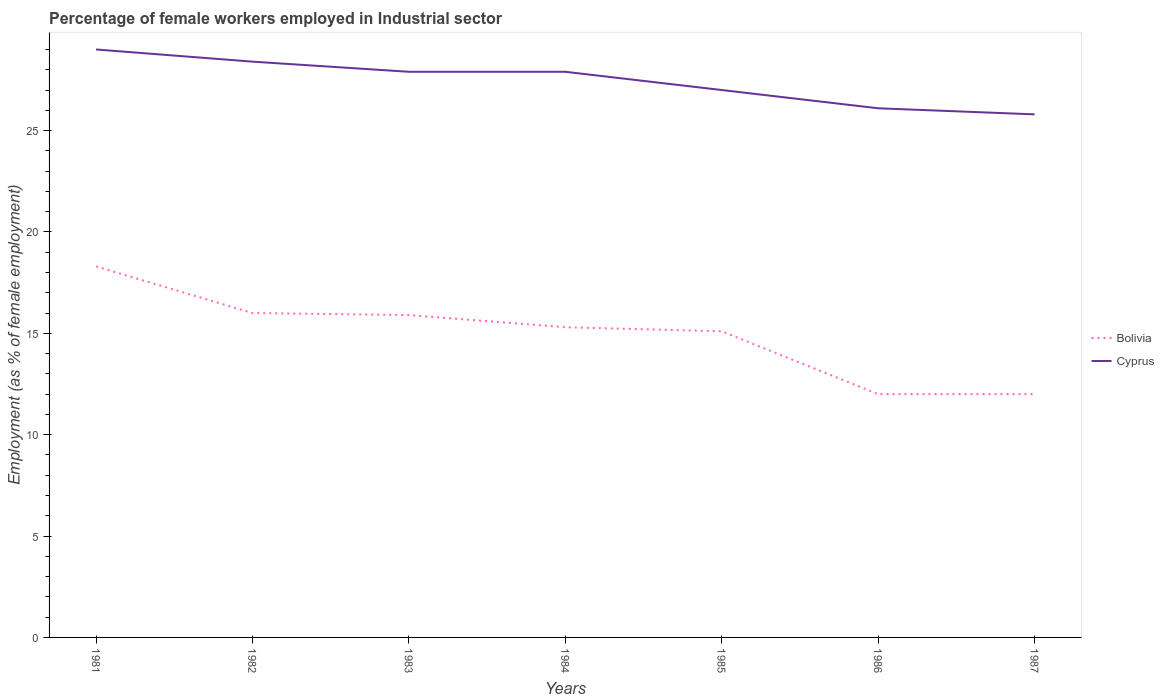How many different coloured lines are there?
Make the answer very short. 2. Does the line corresponding to Bolivia intersect with the line corresponding to Cyprus?
Provide a succinct answer. No. Across all years, what is the maximum percentage of females employed in Industrial sector in Bolivia?
Give a very brief answer. 12. What is the total percentage of females employed in Industrial sector in Bolivia in the graph?
Keep it short and to the point. 6.3. What is the difference between the highest and the second highest percentage of females employed in Industrial sector in Bolivia?
Provide a succinct answer. 6.3. Is the percentage of females employed in Industrial sector in Bolivia strictly greater than the percentage of females employed in Industrial sector in Cyprus over the years?
Ensure brevity in your answer.  Yes. How many lines are there?
Ensure brevity in your answer.  2. What is the difference between two consecutive major ticks on the Y-axis?
Make the answer very short. 5. Does the graph contain grids?
Your answer should be very brief. No. Where does the legend appear in the graph?
Offer a terse response. Center right. What is the title of the graph?
Provide a succinct answer. Percentage of female workers employed in Industrial sector. What is the label or title of the X-axis?
Your answer should be very brief. Years. What is the label or title of the Y-axis?
Offer a terse response. Employment (as % of female employment). What is the Employment (as % of female employment) in Bolivia in 1981?
Make the answer very short. 18.3. What is the Employment (as % of female employment) in Cyprus in 1981?
Your response must be concise. 29. What is the Employment (as % of female employment) of Cyprus in 1982?
Keep it short and to the point. 28.4. What is the Employment (as % of female employment) in Bolivia in 1983?
Offer a very short reply. 15.9. What is the Employment (as % of female employment) of Cyprus in 1983?
Offer a terse response. 27.9. What is the Employment (as % of female employment) in Bolivia in 1984?
Make the answer very short. 15.3. What is the Employment (as % of female employment) of Cyprus in 1984?
Provide a short and direct response. 27.9. What is the Employment (as % of female employment) in Bolivia in 1985?
Keep it short and to the point. 15.1. What is the Employment (as % of female employment) in Bolivia in 1986?
Offer a terse response. 12. What is the Employment (as % of female employment) in Cyprus in 1986?
Provide a short and direct response. 26.1. What is the Employment (as % of female employment) in Bolivia in 1987?
Your response must be concise. 12. What is the Employment (as % of female employment) of Cyprus in 1987?
Offer a terse response. 25.8. Across all years, what is the maximum Employment (as % of female employment) of Bolivia?
Give a very brief answer. 18.3. Across all years, what is the maximum Employment (as % of female employment) in Cyprus?
Provide a succinct answer. 29. Across all years, what is the minimum Employment (as % of female employment) in Bolivia?
Offer a very short reply. 12. Across all years, what is the minimum Employment (as % of female employment) in Cyprus?
Make the answer very short. 25.8. What is the total Employment (as % of female employment) of Bolivia in the graph?
Offer a terse response. 104.6. What is the total Employment (as % of female employment) of Cyprus in the graph?
Your response must be concise. 192.1. What is the difference between the Employment (as % of female employment) in Bolivia in 1981 and that in 1982?
Offer a very short reply. 2.3. What is the difference between the Employment (as % of female employment) in Bolivia in 1981 and that in 1983?
Your answer should be very brief. 2.4. What is the difference between the Employment (as % of female employment) of Bolivia in 1981 and that in 1984?
Make the answer very short. 3. What is the difference between the Employment (as % of female employment) in Bolivia in 1981 and that in 1985?
Keep it short and to the point. 3.2. What is the difference between the Employment (as % of female employment) of Bolivia in 1981 and that in 1986?
Give a very brief answer. 6.3. What is the difference between the Employment (as % of female employment) of Bolivia in 1982 and that in 1983?
Your answer should be compact. 0.1. What is the difference between the Employment (as % of female employment) in Bolivia in 1982 and that in 1984?
Keep it short and to the point. 0.7. What is the difference between the Employment (as % of female employment) of Cyprus in 1982 and that in 1984?
Make the answer very short. 0.5. What is the difference between the Employment (as % of female employment) in Cyprus in 1982 and that in 1985?
Offer a terse response. 1.4. What is the difference between the Employment (as % of female employment) in Bolivia in 1982 and that in 1986?
Your response must be concise. 4. What is the difference between the Employment (as % of female employment) in Cyprus in 1982 and that in 1986?
Offer a terse response. 2.3. What is the difference between the Employment (as % of female employment) of Bolivia in 1983 and that in 1984?
Give a very brief answer. 0.6. What is the difference between the Employment (as % of female employment) of Cyprus in 1983 and that in 1984?
Your answer should be very brief. 0. What is the difference between the Employment (as % of female employment) of Bolivia in 1983 and that in 1985?
Offer a terse response. 0.8. What is the difference between the Employment (as % of female employment) in Cyprus in 1983 and that in 1985?
Make the answer very short. 0.9. What is the difference between the Employment (as % of female employment) in Cyprus in 1983 and that in 1986?
Your answer should be very brief. 1.8. What is the difference between the Employment (as % of female employment) in Bolivia in 1984 and that in 1985?
Provide a short and direct response. 0.2. What is the difference between the Employment (as % of female employment) of Cyprus in 1984 and that in 1985?
Your answer should be very brief. 0.9. What is the difference between the Employment (as % of female employment) in Cyprus in 1984 and that in 1986?
Give a very brief answer. 1.8. What is the difference between the Employment (as % of female employment) in Cyprus in 1984 and that in 1987?
Keep it short and to the point. 2.1. What is the difference between the Employment (as % of female employment) of Cyprus in 1985 and that in 1986?
Make the answer very short. 0.9. What is the difference between the Employment (as % of female employment) in Cyprus in 1985 and that in 1987?
Keep it short and to the point. 1.2. What is the difference between the Employment (as % of female employment) in Cyprus in 1986 and that in 1987?
Offer a terse response. 0.3. What is the difference between the Employment (as % of female employment) in Bolivia in 1981 and the Employment (as % of female employment) in Cyprus in 1982?
Provide a short and direct response. -10.1. What is the difference between the Employment (as % of female employment) of Bolivia in 1981 and the Employment (as % of female employment) of Cyprus in 1984?
Offer a terse response. -9.6. What is the difference between the Employment (as % of female employment) in Bolivia in 1981 and the Employment (as % of female employment) in Cyprus in 1987?
Your answer should be very brief. -7.5. What is the difference between the Employment (as % of female employment) in Bolivia in 1982 and the Employment (as % of female employment) in Cyprus in 1984?
Make the answer very short. -11.9. What is the difference between the Employment (as % of female employment) in Bolivia in 1982 and the Employment (as % of female employment) in Cyprus in 1985?
Keep it short and to the point. -11. What is the difference between the Employment (as % of female employment) in Bolivia in 1983 and the Employment (as % of female employment) in Cyprus in 1985?
Provide a succinct answer. -11.1. What is the difference between the Employment (as % of female employment) of Bolivia in 1983 and the Employment (as % of female employment) of Cyprus in 1987?
Provide a short and direct response. -9.9. What is the difference between the Employment (as % of female employment) of Bolivia in 1985 and the Employment (as % of female employment) of Cyprus in 1986?
Give a very brief answer. -11. What is the difference between the Employment (as % of female employment) in Bolivia in 1985 and the Employment (as % of female employment) in Cyprus in 1987?
Offer a very short reply. -10.7. What is the average Employment (as % of female employment) of Bolivia per year?
Keep it short and to the point. 14.94. What is the average Employment (as % of female employment) of Cyprus per year?
Offer a terse response. 27.44. In the year 1982, what is the difference between the Employment (as % of female employment) in Bolivia and Employment (as % of female employment) in Cyprus?
Keep it short and to the point. -12.4. In the year 1984, what is the difference between the Employment (as % of female employment) of Bolivia and Employment (as % of female employment) of Cyprus?
Offer a very short reply. -12.6. In the year 1986, what is the difference between the Employment (as % of female employment) in Bolivia and Employment (as % of female employment) in Cyprus?
Ensure brevity in your answer.  -14.1. What is the ratio of the Employment (as % of female employment) of Bolivia in 1981 to that in 1982?
Provide a short and direct response. 1.14. What is the ratio of the Employment (as % of female employment) in Cyprus in 1981 to that in 1982?
Make the answer very short. 1.02. What is the ratio of the Employment (as % of female employment) of Bolivia in 1981 to that in 1983?
Keep it short and to the point. 1.15. What is the ratio of the Employment (as % of female employment) in Cyprus in 1981 to that in 1983?
Provide a short and direct response. 1.04. What is the ratio of the Employment (as % of female employment) in Bolivia in 1981 to that in 1984?
Make the answer very short. 1.2. What is the ratio of the Employment (as % of female employment) of Cyprus in 1981 to that in 1984?
Your answer should be very brief. 1.04. What is the ratio of the Employment (as % of female employment) of Bolivia in 1981 to that in 1985?
Keep it short and to the point. 1.21. What is the ratio of the Employment (as % of female employment) of Cyprus in 1981 to that in 1985?
Provide a succinct answer. 1.07. What is the ratio of the Employment (as % of female employment) in Bolivia in 1981 to that in 1986?
Keep it short and to the point. 1.52. What is the ratio of the Employment (as % of female employment) in Bolivia in 1981 to that in 1987?
Your answer should be very brief. 1.52. What is the ratio of the Employment (as % of female employment) in Cyprus in 1981 to that in 1987?
Make the answer very short. 1.12. What is the ratio of the Employment (as % of female employment) of Cyprus in 1982 to that in 1983?
Make the answer very short. 1.02. What is the ratio of the Employment (as % of female employment) in Bolivia in 1982 to that in 1984?
Give a very brief answer. 1.05. What is the ratio of the Employment (as % of female employment) in Cyprus in 1982 to that in 1984?
Your response must be concise. 1.02. What is the ratio of the Employment (as % of female employment) of Bolivia in 1982 to that in 1985?
Keep it short and to the point. 1.06. What is the ratio of the Employment (as % of female employment) in Cyprus in 1982 to that in 1985?
Provide a succinct answer. 1.05. What is the ratio of the Employment (as % of female employment) of Cyprus in 1982 to that in 1986?
Offer a very short reply. 1.09. What is the ratio of the Employment (as % of female employment) of Bolivia in 1982 to that in 1987?
Offer a terse response. 1.33. What is the ratio of the Employment (as % of female employment) of Cyprus in 1982 to that in 1987?
Your answer should be very brief. 1.1. What is the ratio of the Employment (as % of female employment) in Bolivia in 1983 to that in 1984?
Keep it short and to the point. 1.04. What is the ratio of the Employment (as % of female employment) of Cyprus in 1983 to that in 1984?
Provide a short and direct response. 1. What is the ratio of the Employment (as % of female employment) in Bolivia in 1983 to that in 1985?
Provide a succinct answer. 1.05. What is the ratio of the Employment (as % of female employment) of Cyprus in 1983 to that in 1985?
Offer a terse response. 1.03. What is the ratio of the Employment (as % of female employment) of Bolivia in 1983 to that in 1986?
Your answer should be very brief. 1.32. What is the ratio of the Employment (as % of female employment) of Cyprus in 1983 to that in 1986?
Provide a short and direct response. 1.07. What is the ratio of the Employment (as % of female employment) of Bolivia in 1983 to that in 1987?
Ensure brevity in your answer.  1.32. What is the ratio of the Employment (as % of female employment) in Cyprus in 1983 to that in 1987?
Provide a succinct answer. 1.08. What is the ratio of the Employment (as % of female employment) in Bolivia in 1984 to that in 1985?
Give a very brief answer. 1.01. What is the ratio of the Employment (as % of female employment) of Cyprus in 1984 to that in 1985?
Give a very brief answer. 1.03. What is the ratio of the Employment (as % of female employment) in Bolivia in 1984 to that in 1986?
Your answer should be very brief. 1.27. What is the ratio of the Employment (as % of female employment) in Cyprus in 1984 to that in 1986?
Your answer should be very brief. 1.07. What is the ratio of the Employment (as % of female employment) in Bolivia in 1984 to that in 1987?
Your response must be concise. 1.27. What is the ratio of the Employment (as % of female employment) of Cyprus in 1984 to that in 1987?
Provide a succinct answer. 1.08. What is the ratio of the Employment (as % of female employment) in Bolivia in 1985 to that in 1986?
Make the answer very short. 1.26. What is the ratio of the Employment (as % of female employment) of Cyprus in 1985 to that in 1986?
Make the answer very short. 1.03. What is the ratio of the Employment (as % of female employment) of Bolivia in 1985 to that in 1987?
Make the answer very short. 1.26. What is the ratio of the Employment (as % of female employment) in Cyprus in 1985 to that in 1987?
Offer a terse response. 1.05. What is the ratio of the Employment (as % of female employment) of Bolivia in 1986 to that in 1987?
Provide a short and direct response. 1. What is the ratio of the Employment (as % of female employment) of Cyprus in 1986 to that in 1987?
Make the answer very short. 1.01. What is the difference between the highest and the second highest Employment (as % of female employment) in Bolivia?
Offer a very short reply. 2.3. What is the difference between the highest and the lowest Employment (as % of female employment) in Bolivia?
Ensure brevity in your answer.  6.3. 